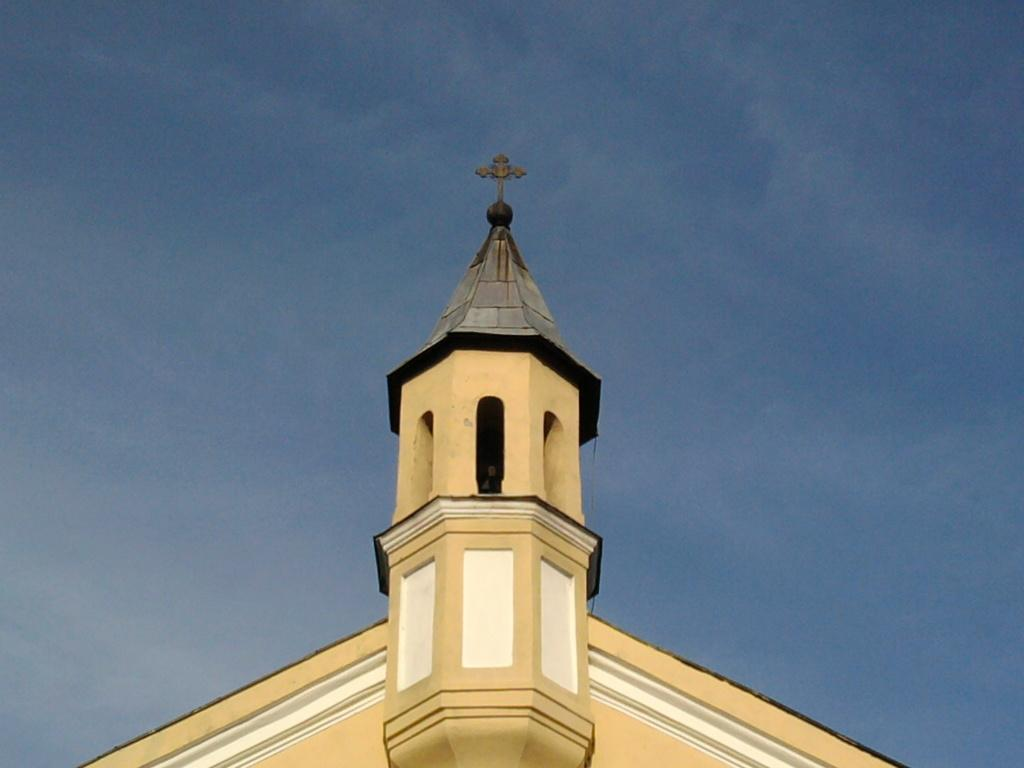What type of structure is shown in the image? The image shows the top of a building. What architectural feature can be seen on the building? The building has arches. What religious symbol is present on top of the building? There is a cross on top of the building. What can be seen in the background of the image? The sky is visible in the background of the image. How many passengers are waiting to board the peace in the image? There is no reference to passengers or peace in the image; it shows the top of a building with arches and a cross. 